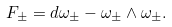<formula> <loc_0><loc_0><loc_500><loc_500>F _ { \pm } = d \omega _ { \pm } - \omega _ { \pm } \wedge \omega _ { \pm } .</formula> 